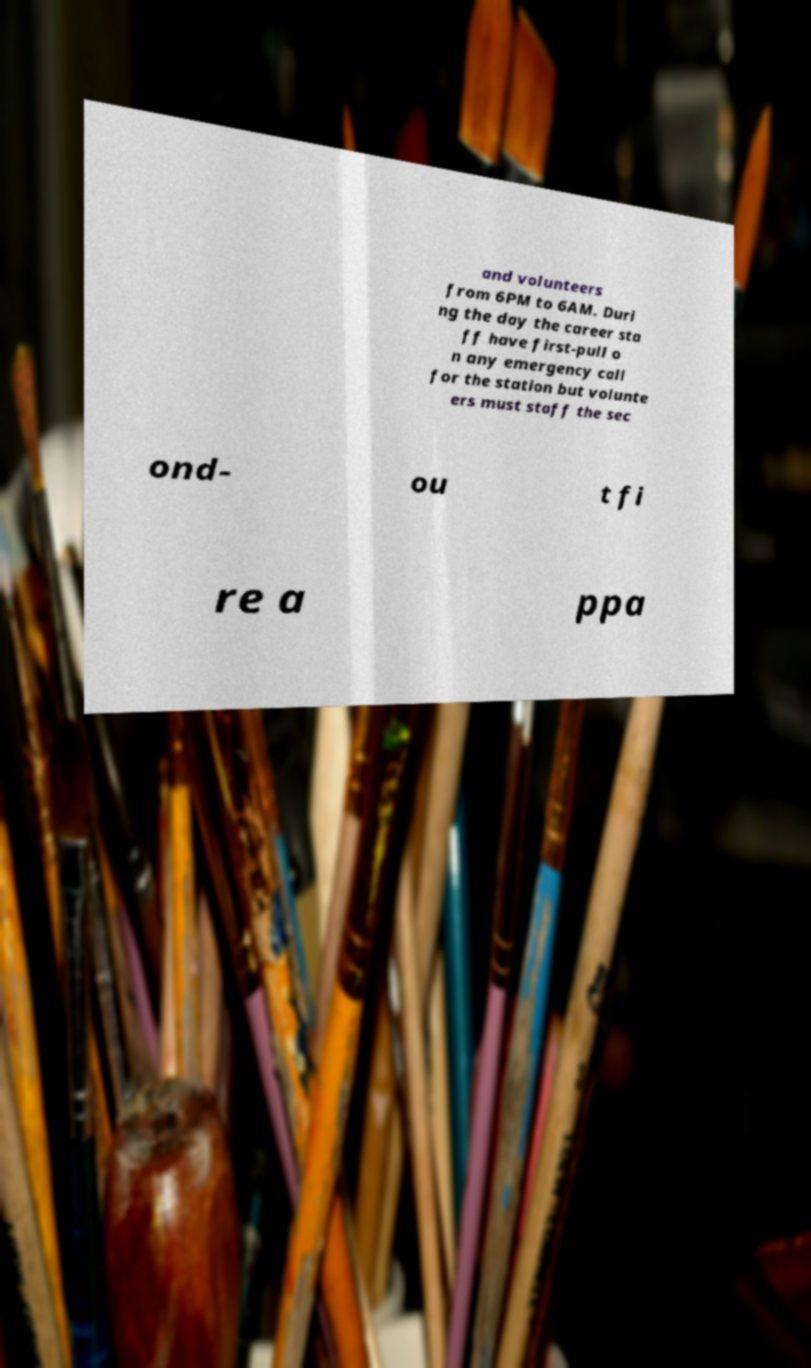I need the written content from this picture converted into text. Can you do that? and volunteers from 6PM to 6AM. Duri ng the day the career sta ff have first-pull o n any emergency call for the station but volunte ers must staff the sec ond- ou t fi re a ppa 